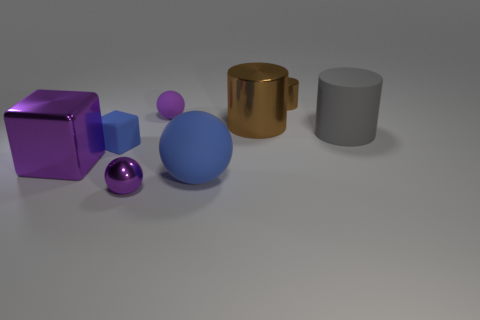Add 1 big brown things. How many objects exist? 9 Subtract all cubes. How many objects are left? 6 Add 5 tiny blocks. How many tiny blocks are left? 6 Add 5 purple blocks. How many purple blocks exist? 6 Subtract 0 red blocks. How many objects are left? 8 Subtract all cyan objects. Subtract all small shiny things. How many objects are left? 6 